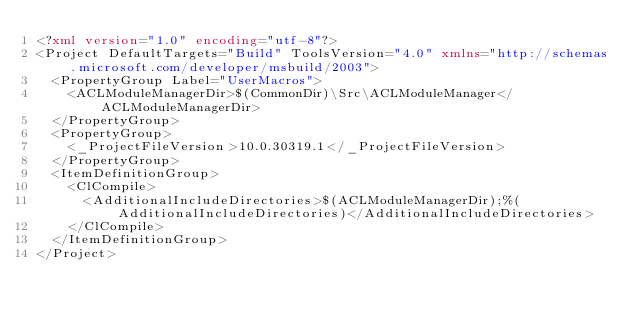Convert code to text. <code><loc_0><loc_0><loc_500><loc_500><_XML_><?xml version="1.0" encoding="utf-8"?>
<Project DefaultTargets="Build" ToolsVersion="4.0" xmlns="http://schemas.microsoft.com/developer/msbuild/2003">
  <PropertyGroup Label="UserMacros">
    <ACLModuleManagerDir>$(CommonDir)\Src\ACLModuleManager</ACLModuleManagerDir>
  </PropertyGroup>
  <PropertyGroup>
    <_ProjectFileVersion>10.0.30319.1</_ProjectFileVersion>
  </PropertyGroup>
  <ItemDefinitionGroup>
    <ClCompile>
      <AdditionalIncludeDirectories>$(ACLModuleManagerDir);%(AdditionalIncludeDirectories)</AdditionalIncludeDirectories>
    </ClCompile>
  </ItemDefinitionGroup>
</Project>
</code> 